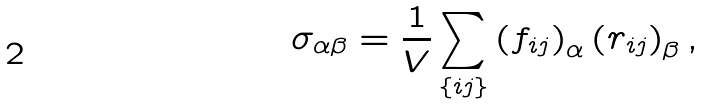Convert formula to latex. <formula><loc_0><loc_0><loc_500><loc_500>\sigma _ { \alpha \beta } = \frac { 1 } { V } \sum _ { \{ i j \} } \left ( { f } _ { i j } \right ) _ { \alpha } \left ( { r } _ { i j } \right ) _ { \beta } ,</formula> 